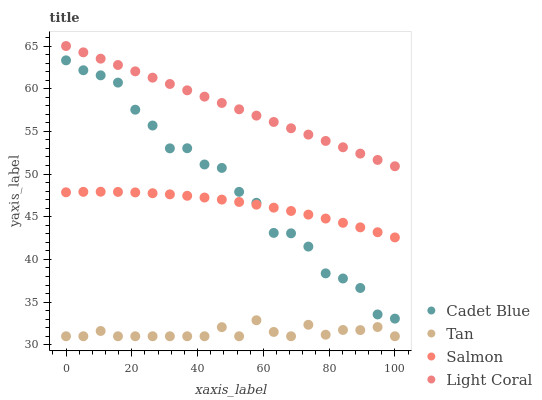Does Tan have the minimum area under the curve?
Answer yes or no. Yes. Does Light Coral have the maximum area under the curve?
Answer yes or no. Yes. Does Cadet Blue have the minimum area under the curve?
Answer yes or no. No. Does Cadet Blue have the maximum area under the curve?
Answer yes or no. No. Is Light Coral the smoothest?
Answer yes or no. Yes. Is Cadet Blue the roughest?
Answer yes or no. Yes. Is Tan the smoothest?
Answer yes or no. No. Is Tan the roughest?
Answer yes or no. No. Does Tan have the lowest value?
Answer yes or no. Yes. Does Cadet Blue have the lowest value?
Answer yes or no. No. Does Light Coral have the highest value?
Answer yes or no. Yes. Does Cadet Blue have the highest value?
Answer yes or no. No. Is Tan less than Light Coral?
Answer yes or no. Yes. Is Salmon greater than Tan?
Answer yes or no. Yes. Does Salmon intersect Cadet Blue?
Answer yes or no. Yes. Is Salmon less than Cadet Blue?
Answer yes or no. No. Is Salmon greater than Cadet Blue?
Answer yes or no. No. Does Tan intersect Light Coral?
Answer yes or no. No. 